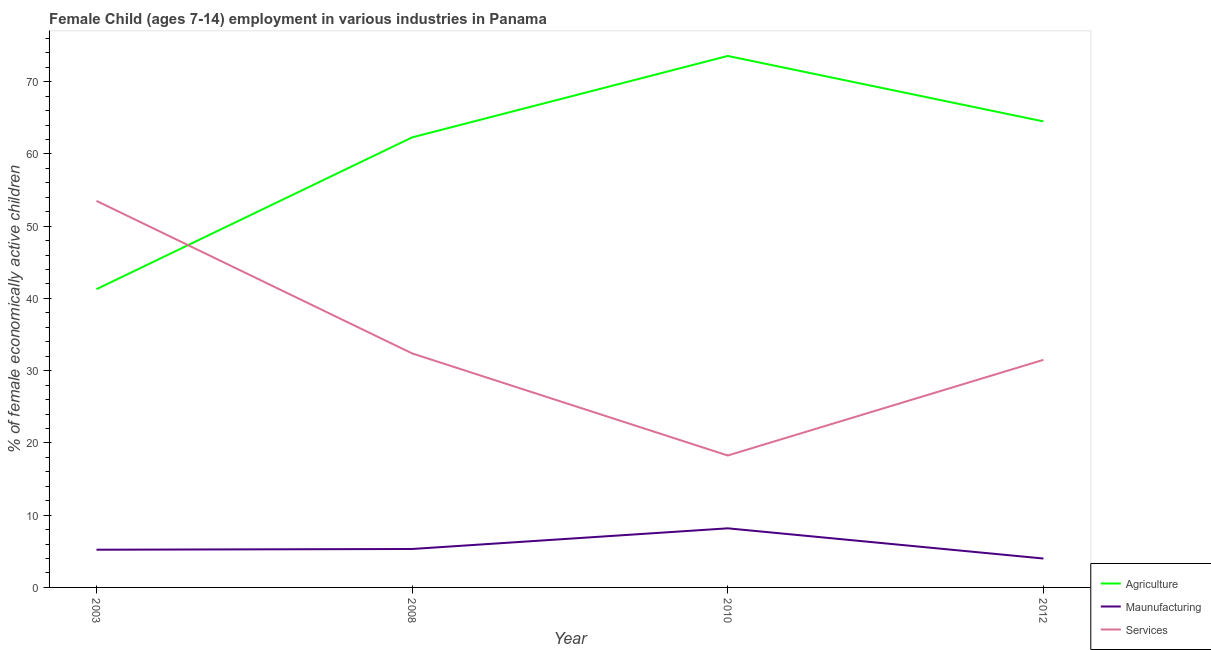Does the line corresponding to percentage of economically active children in manufacturing intersect with the line corresponding to percentage of economically active children in services?
Provide a succinct answer. No. Is the number of lines equal to the number of legend labels?
Ensure brevity in your answer.  Yes. What is the percentage of economically active children in agriculture in 2003?
Provide a succinct answer. 41.28. Across all years, what is the maximum percentage of economically active children in agriculture?
Provide a succinct answer. 73.56. In which year was the percentage of economically active children in services minimum?
Provide a succinct answer. 2010. What is the total percentage of economically active children in services in the graph?
Your response must be concise. 135.65. What is the difference between the percentage of economically active children in manufacturing in 2010 and that in 2012?
Offer a terse response. 4.18. What is the difference between the percentage of economically active children in agriculture in 2008 and the percentage of economically active children in services in 2003?
Provide a short and direct response. 8.79. What is the average percentage of economically active children in manufacturing per year?
Your answer should be very brief. 5.68. In the year 2003, what is the difference between the percentage of economically active children in services and percentage of economically active children in agriculture?
Your response must be concise. 12.22. In how many years, is the percentage of economically active children in agriculture greater than 32 %?
Provide a short and direct response. 4. What is the ratio of the percentage of economically active children in manufacturing in 2003 to that in 2008?
Provide a succinct answer. 0.98. Is the difference between the percentage of economically active children in agriculture in 2008 and 2012 greater than the difference between the percentage of economically active children in services in 2008 and 2012?
Your response must be concise. No. What is the difference between the highest and the second highest percentage of economically active children in services?
Provide a short and direct response. 21.11. What is the difference between the highest and the lowest percentage of economically active children in services?
Offer a terse response. 35.24. In how many years, is the percentage of economically active children in manufacturing greater than the average percentage of economically active children in manufacturing taken over all years?
Ensure brevity in your answer.  1. Is the sum of the percentage of economically active children in services in 2003 and 2010 greater than the maximum percentage of economically active children in agriculture across all years?
Keep it short and to the point. No. Is it the case that in every year, the sum of the percentage of economically active children in agriculture and percentage of economically active children in manufacturing is greater than the percentage of economically active children in services?
Your answer should be very brief. No. Does the percentage of economically active children in manufacturing monotonically increase over the years?
Provide a succinct answer. No. Is the percentage of economically active children in services strictly less than the percentage of economically active children in agriculture over the years?
Offer a terse response. No. How many lines are there?
Keep it short and to the point. 3. What is the difference between two consecutive major ticks on the Y-axis?
Provide a succinct answer. 10. Are the values on the major ticks of Y-axis written in scientific E-notation?
Provide a short and direct response. No. Does the graph contain any zero values?
Provide a short and direct response. No. Does the graph contain grids?
Your answer should be compact. No. Where does the legend appear in the graph?
Offer a very short reply. Bottom right. What is the title of the graph?
Your answer should be compact. Female Child (ages 7-14) employment in various industries in Panama. What is the label or title of the Y-axis?
Offer a very short reply. % of female economically active children. What is the % of female economically active children of Agriculture in 2003?
Your answer should be compact. 41.28. What is the % of female economically active children of Maunufacturing in 2003?
Offer a terse response. 5.22. What is the % of female economically active children in Services in 2003?
Offer a terse response. 53.5. What is the % of female economically active children of Agriculture in 2008?
Provide a succinct answer. 62.29. What is the % of female economically active children of Maunufacturing in 2008?
Make the answer very short. 5.32. What is the % of female economically active children of Services in 2008?
Provide a short and direct response. 32.39. What is the % of female economically active children in Agriculture in 2010?
Your answer should be very brief. 73.56. What is the % of female economically active children in Maunufacturing in 2010?
Ensure brevity in your answer.  8.18. What is the % of female economically active children in Services in 2010?
Keep it short and to the point. 18.26. What is the % of female economically active children in Agriculture in 2012?
Provide a short and direct response. 64.5. What is the % of female economically active children of Maunufacturing in 2012?
Your response must be concise. 4. What is the % of female economically active children of Services in 2012?
Your response must be concise. 31.5. Across all years, what is the maximum % of female economically active children in Agriculture?
Your answer should be compact. 73.56. Across all years, what is the maximum % of female economically active children in Maunufacturing?
Your response must be concise. 8.18. Across all years, what is the maximum % of female economically active children in Services?
Offer a terse response. 53.5. Across all years, what is the minimum % of female economically active children in Agriculture?
Provide a short and direct response. 41.28. Across all years, what is the minimum % of female economically active children of Maunufacturing?
Provide a succinct answer. 4. Across all years, what is the minimum % of female economically active children in Services?
Provide a short and direct response. 18.26. What is the total % of female economically active children of Agriculture in the graph?
Your answer should be very brief. 241.63. What is the total % of female economically active children of Maunufacturing in the graph?
Give a very brief answer. 22.72. What is the total % of female economically active children in Services in the graph?
Your answer should be compact. 135.65. What is the difference between the % of female economically active children in Agriculture in 2003 and that in 2008?
Provide a succinct answer. -21.01. What is the difference between the % of female economically active children in Services in 2003 and that in 2008?
Offer a terse response. 21.11. What is the difference between the % of female economically active children in Agriculture in 2003 and that in 2010?
Provide a short and direct response. -32.28. What is the difference between the % of female economically active children of Maunufacturing in 2003 and that in 2010?
Your response must be concise. -2.96. What is the difference between the % of female economically active children in Services in 2003 and that in 2010?
Your answer should be compact. 35.24. What is the difference between the % of female economically active children of Agriculture in 2003 and that in 2012?
Provide a short and direct response. -23.22. What is the difference between the % of female economically active children in Maunufacturing in 2003 and that in 2012?
Your response must be concise. 1.22. What is the difference between the % of female economically active children of Services in 2003 and that in 2012?
Keep it short and to the point. 22. What is the difference between the % of female economically active children of Agriculture in 2008 and that in 2010?
Your answer should be very brief. -11.27. What is the difference between the % of female economically active children of Maunufacturing in 2008 and that in 2010?
Give a very brief answer. -2.86. What is the difference between the % of female economically active children of Services in 2008 and that in 2010?
Keep it short and to the point. 14.13. What is the difference between the % of female economically active children of Agriculture in 2008 and that in 2012?
Provide a succinct answer. -2.21. What is the difference between the % of female economically active children in Maunufacturing in 2008 and that in 2012?
Provide a short and direct response. 1.32. What is the difference between the % of female economically active children of Services in 2008 and that in 2012?
Your response must be concise. 0.89. What is the difference between the % of female economically active children of Agriculture in 2010 and that in 2012?
Keep it short and to the point. 9.06. What is the difference between the % of female economically active children of Maunufacturing in 2010 and that in 2012?
Offer a very short reply. 4.18. What is the difference between the % of female economically active children of Services in 2010 and that in 2012?
Provide a succinct answer. -13.24. What is the difference between the % of female economically active children in Agriculture in 2003 and the % of female economically active children in Maunufacturing in 2008?
Offer a very short reply. 35.96. What is the difference between the % of female economically active children in Agriculture in 2003 and the % of female economically active children in Services in 2008?
Keep it short and to the point. 8.89. What is the difference between the % of female economically active children of Maunufacturing in 2003 and the % of female economically active children of Services in 2008?
Your response must be concise. -27.17. What is the difference between the % of female economically active children of Agriculture in 2003 and the % of female economically active children of Maunufacturing in 2010?
Ensure brevity in your answer.  33.1. What is the difference between the % of female economically active children in Agriculture in 2003 and the % of female economically active children in Services in 2010?
Keep it short and to the point. 23.02. What is the difference between the % of female economically active children of Maunufacturing in 2003 and the % of female economically active children of Services in 2010?
Your answer should be very brief. -13.04. What is the difference between the % of female economically active children of Agriculture in 2003 and the % of female economically active children of Maunufacturing in 2012?
Your answer should be compact. 37.28. What is the difference between the % of female economically active children of Agriculture in 2003 and the % of female economically active children of Services in 2012?
Give a very brief answer. 9.78. What is the difference between the % of female economically active children of Maunufacturing in 2003 and the % of female economically active children of Services in 2012?
Give a very brief answer. -26.28. What is the difference between the % of female economically active children of Agriculture in 2008 and the % of female economically active children of Maunufacturing in 2010?
Make the answer very short. 54.11. What is the difference between the % of female economically active children of Agriculture in 2008 and the % of female economically active children of Services in 2010?
Ensure brevity in your answer.  44.03. What is the difference between the % of female economically active children of Maunufacturing in 2008 and the % of female economically active children of Services in 2010?
Your answer should be very brief. -12.94. What is the difference between the % of female economically active children in Agriculture in 2008 and the % of female economically active children in Maunufacturing in 2012?
Ensure brevity in your answer.  58.29. What is the difference between the % of female economically active children in Agriculture in 2008 and the % of female economically active children in Services in 2012?
Keep it short and to the point. 30.79. What is the difference between the % of female economically active children in Maunufacturing in 2008 and the % of female economically active children in Services in 2012?
Offer a very short reply. -26.18. What is the difference between the % of female economically active children of Agriculture in 2010 and the % of female economically active children of Maunufacturing in 2012?
Provide a succinct answer. 69.56. What is the difference between the % of female economically active children in Agriculture in 2010 and the % of female economically active children in Services in 2012?
Make the answer very short. 42.06. What is the difference between the % of female economically active children in Maunufacturing in 2010 and the % of female economically active children in Services in 2012?
Your answer should be compact. -23.32. What is the average % of female economically active children in Agriculture per year?
Make the answer very short. 60.41. What is the average % of female economically active children of Maunufacturing per year?
Your answer should be very brief. 5.68. What is the average % of female economically active children of Services per year?
Offer a very short reply. 33.91. In the year 2003, what is the difference between the % of female economically active children in Agriculture and % of female economically active children in Maunufacturing?
Make the answer very short. 36.06. In the year 2003, what is the difference between the % of female economically active children of Agriculture and % of female economically active children of Services?
Offer a terse response. -12.22. In the year 2003, what is the difference between the % of female economically active children of Maunufacturing and % of female economically active children of Services?
Keep it short and to the point. -48.28. In the year 2008, what is the difference between the % of female economically active children in Agriculture and % of female economically active children in Maunufacturing?
Offer a very short reply. 56.97. In the year 2008, what is the difference between the % of female economically active children in Agriculture and % of female economically active children in Services?
Make the answer very short. 29.9. In the year 2008, what is the difference between the % of female economically active children in Maunufacturing and % of female economically active children in Services?
Provide a succinct answer. -27.07. In the year 2010, what is the difference between the % of female economically active children of Agriculture and % of female economically active children of Maunufacturing?
Give a very brief answer. 65.38. In the year 2010, what is the difference between the % of female economically active children of Agriculture and % of female economically active children of Services?
Provide a succinct answer. 55.3. In the year 2010, what is the difference between the % of female economically active children of Maunufacturing and % of female economically active children of Services?
Keep it short and to the point. -10.08. In the year 2012, what is the difference between the % of female economically active children of Agriculture and % of female economically active children of Maunufacturing?
Your answer should be compact. 60.5. In the year 2012, what is the difference between the % of female economically active children of Maunufacturing and % of female economically active children of Services?
Offer a very short reply. -27.5. What is the ratio of the % of female economically active children of Agriculture in 2003 to that in 2008?
Keep it short and to the point. 0.66. What is the ratio of the % of female economically active children in Maunufacturing in 2003 to that in 2008?
Offer a terse response. 0.98. What is the ratio of the % of female economically active children in Services in 2003 to that in 2008?
Provide a short and direct response. 1.65. What is the ratio of the % of female economically active children in Agriculture in 2003 to that in 2010?
Give a very brief answer. 0.56. What is the ratio of the % of female economically active children of Maunufacturing in 2003 to that in 2010?
Your answer should be very brief. 0.64. What is the ratio of the % of female economically active children of Services in 2003 to that in 2010?
Offer a terse response. 2.93. What is the ratio of the % of female economically active children of Agriculture in 2003 to that in 2012?
Give a very brief answer. 0.64. What is the ratio of the % of female economically active children in Maunufacturing in 2003 to that in 2012?
Your response must be concise. 1.3. What is the ratio of the % of female economically active children in Services in 2003 to that in 2012?
Provide a short and direct response. 1.7. What is the ratio of the % of female economically active children in Agriculture in 2008 to that in 2010?
Ensure brevity in your answer.  0.85. What is the ratio of the % of female economically active children in Maunufacturing in 2008 to that in 2010?
Your answer should be very brief. 0.65. What is the ratio of the % of female economically active children of Services in 2008 to that in 2010?
Provide a short and direct response. 1.77. What is the ratio of the % of female economically active children in Agriculture in 2008 to that in 2012?
Keep it short and to the point. 0.97. What is the ratio of the % of female economically active children of Maunufacturing in 2008 to that in 2012?
Your response must be concise. 1.33. What is the ratio of the % of female economically active children of Services in 2008 to that in 2012?
Your answer should be compact. 1.03. What is the ratio of the % of female economically active children in Agriculture in 2010 to that in 2012?
Your answer should be compact. 1.14. What is the ratio of the % of female economically active children of Maunufacturing in 2010 to that in 2012?
Offer a very short reply. 2.04. What is the ratio of the % of female economically active children in Services in 2010 to that in 2012?
Your answer should be compact. 0.58. What is the difference between the highest and the second highest % of female economically active children of Agriculture?
Keep it short and to the point. 9.06. What is the difference between the highest and the second highest % of female economically active children of Maunufacturing?
Your answer should be compact. 2.86. What is the difference between the highest and the second highest % of female economically active children in Services?
Provide a short and direct response. 21.11. What is the difference between the highest and the lowest % of female economically active children in Agriculture?
Make the answer very short. 32.28. What is the difference between the highest and the lowest % of female economically active children of Maunufacturing?
Your answer should be compact. 4.18. What is the difference between the highest and the lowest % of female economically active children in Services?
Offer a terse response. 35.24. 